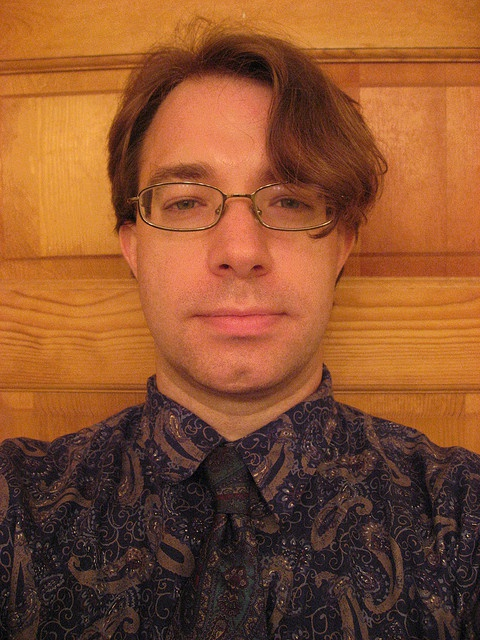Describe the objects in this image and their specific colors. I can see people in red, black, maroon, brown, and salmon tones and tie in red, black, maroon, and brown tones in this image. 